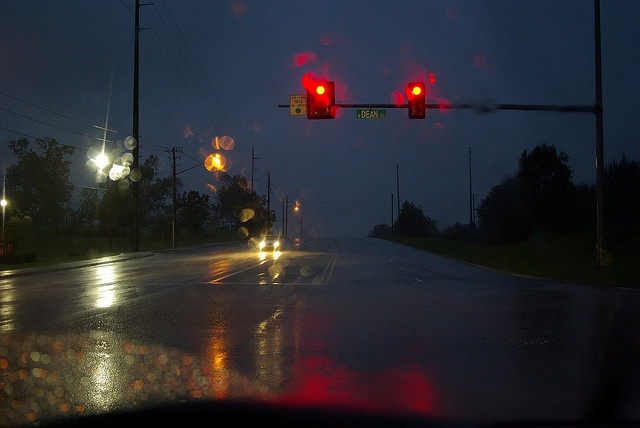Describe the objects in this image and their specific colors. I can see traffic light in black, maroon, and red tones, traffic light in black, maroon, and red tones, and car in black, olive, tan, gray, and ivory tones in this image. 